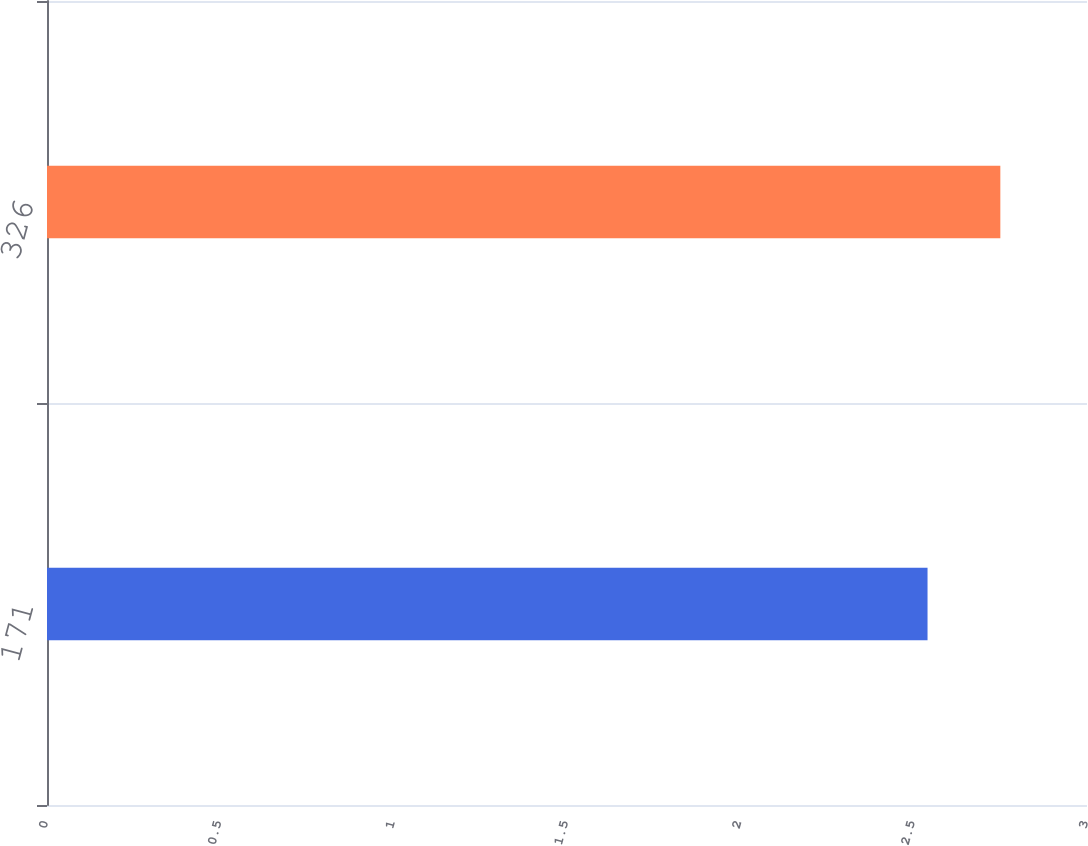<chart> <loc_0><loc_0><loc_500><loc_500><bar_chart><fcel>171<fcel>326<nl><fcel>2.54<fcel>2.75<nl></chart> 